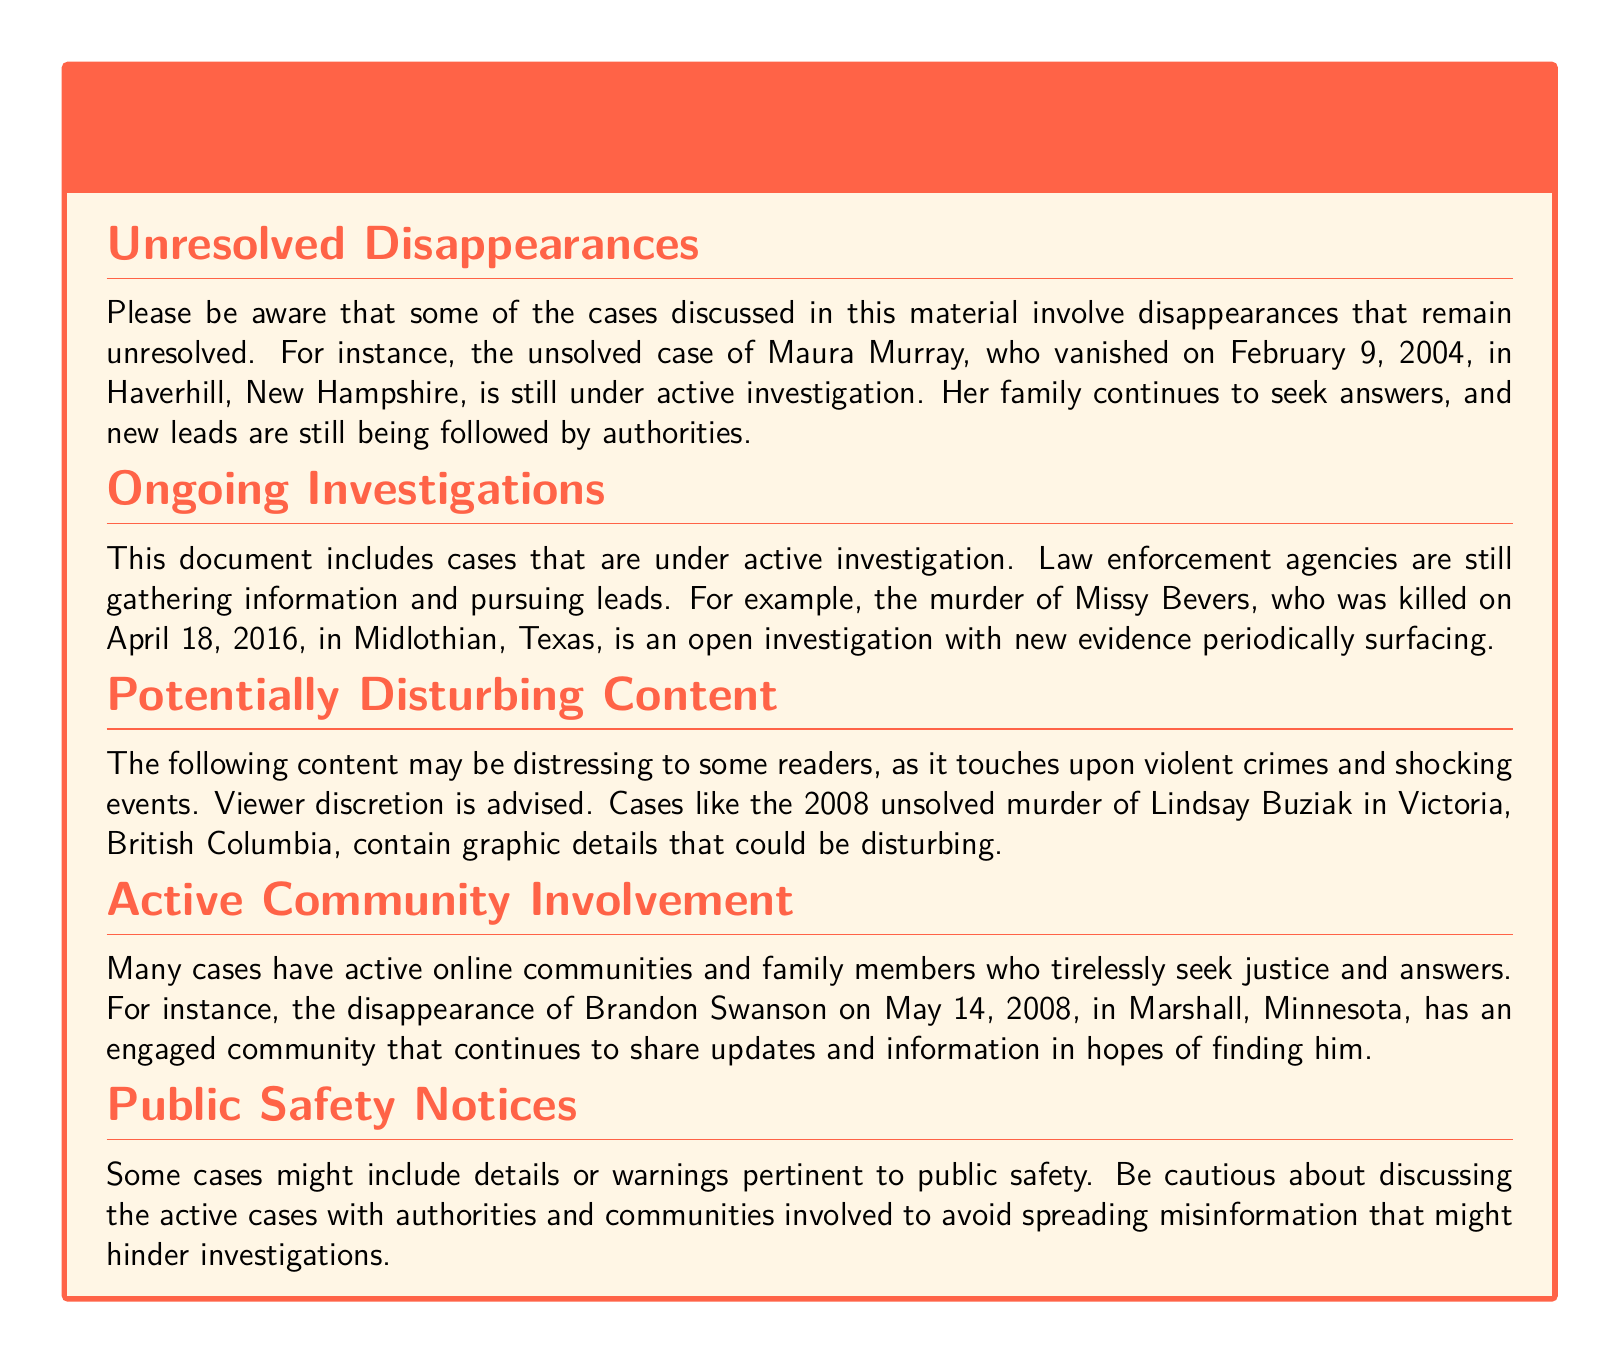what is the title of the warning label? The warning label is titled "Warning: Caution Involves Unresolved Cases and Active Investigations."
Answer: Warning: Caution Involves Unresolved Cases and Active Investigations who is the missing person mentioned in the unresolved disappearances section? The unresolved disappearances section mentions Maura Murray as the missing person.
Answer: Maura Murray when did Maura Murray vanish? The document states that Maura Murray vanished on February 9, 2004.
Answer: February 9, 2004 which case is highlighted as an open investigation related to a murder? The murder of Missy Bevers is highlighted as an open investigation.
Answer: Missy Bevers what year was Lindsay Buziak's murder? The document mentions that Lindsay Buziak was murdered in 2008.
Answer: 2008 what is a noted characteristic of the disappearance of Brandon Swanson? The document states there is an engaged community seeking updates regarding Brandon Swanson's disappearance.
Answer: Active community involvement why should caution be exercised when discussing active cases? Caution should be exercised to avoid spreading misinformation that might hinder investigations.
Answer: Misinformation what type of content may be distressing to readers? The document notes that content involving violent crimes and shocking events may be distressing.
Answer: Violent crimes how should viewers approach the cases discussed? Viewer discretion is advised regarding the potentially disturbing content in the document.
Answer: Viewer discretion advised 